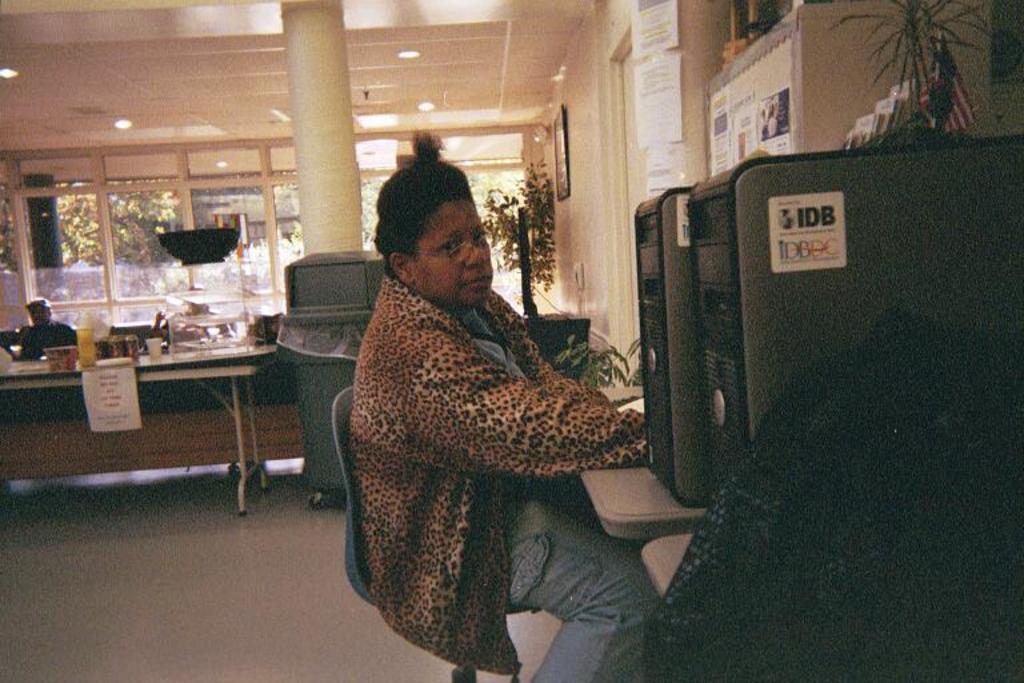What is the person in the image doing? The person is sitting on a chair in the image. What is the person sitting in front of? The person is in front of a system. What can be seen in the background of the image? There is a table, objects on the table, glass windows, trees, and a pillar visible in the background of the image. What flavor of ice cream are the boys enjoying in the image? There are no boys or ice cream present in the image. 